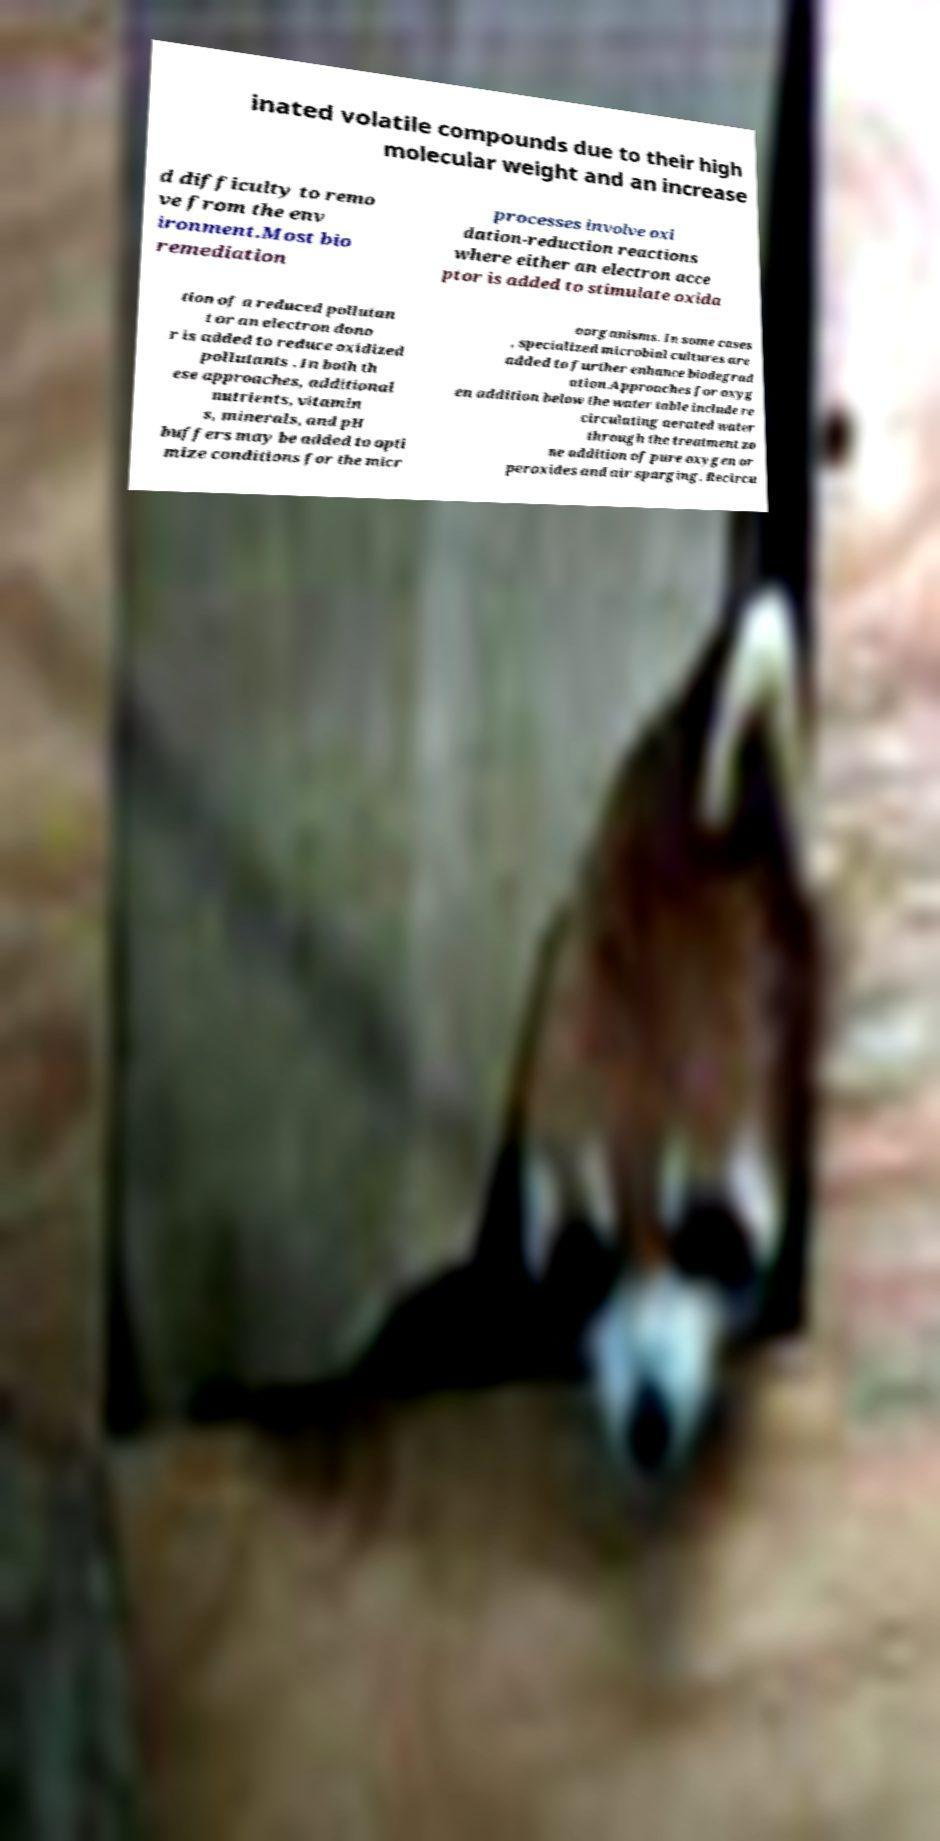Please read and relay the text visible in this image. What does it say? inated volatile compounds due to their high molecular weight and an increase d difficulty to remo ve from the env ironment.Most bio remediation processes involve oxi dation-reduction reactions where either an electron acce ptor is added to stimulate oxida tion of a reduced pollutan t or an electron dono r is added to reduce oxidized pollutants . In both th ese approaches, additional nutrients, vitamin s, minerals, and pH buffers may be added to opti mize conditions for the micr oorganisms. In some cases , specialized microbial cultures are added to further enhance biodegrad ation.Approaches for oxyg en addition below the water table include re circulating aerated water through the treatment zo ne addition of pure oxygen or peroxides and air sparging. Recircu 